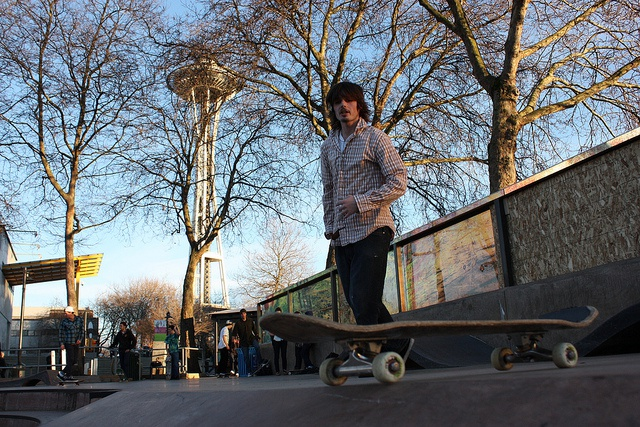Describe the objects in this image and their specific colors. I can see people in gray, black, and maroon tones, skateboard in gray, black, and maroon tones, people in gray, black, blue, darkblue, and maroon tones, people in gray, black, navy, maroon, and blue tones, and people in gray, black, and maroon tones in this image. 